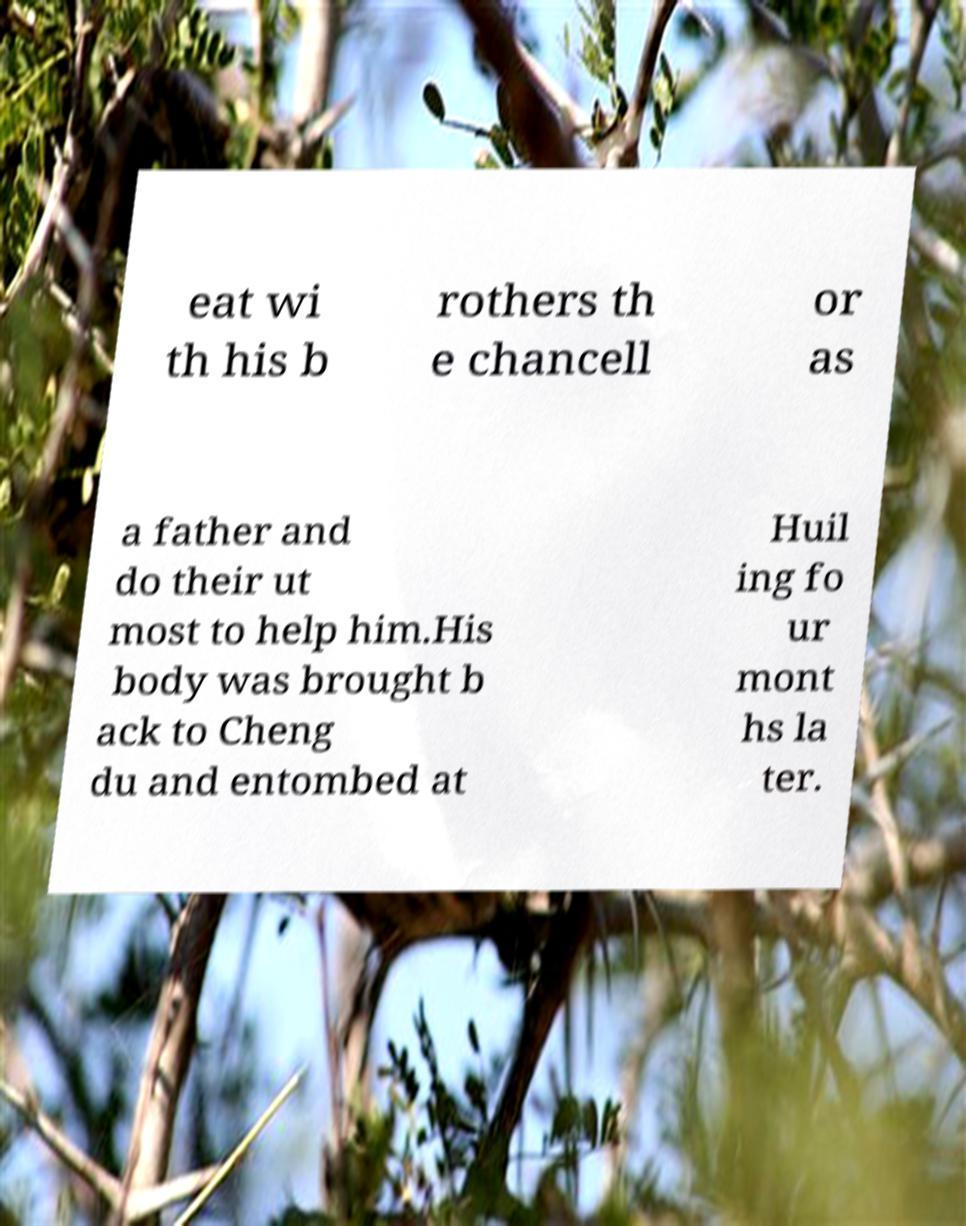Could you extract and type out the text from this image? eat wi th his b rothers th e chancell or as a father and do their ut most to help him.His body was brought b ack to Cheng du and entombed at Huil ing fo ur mont hs la ter. 